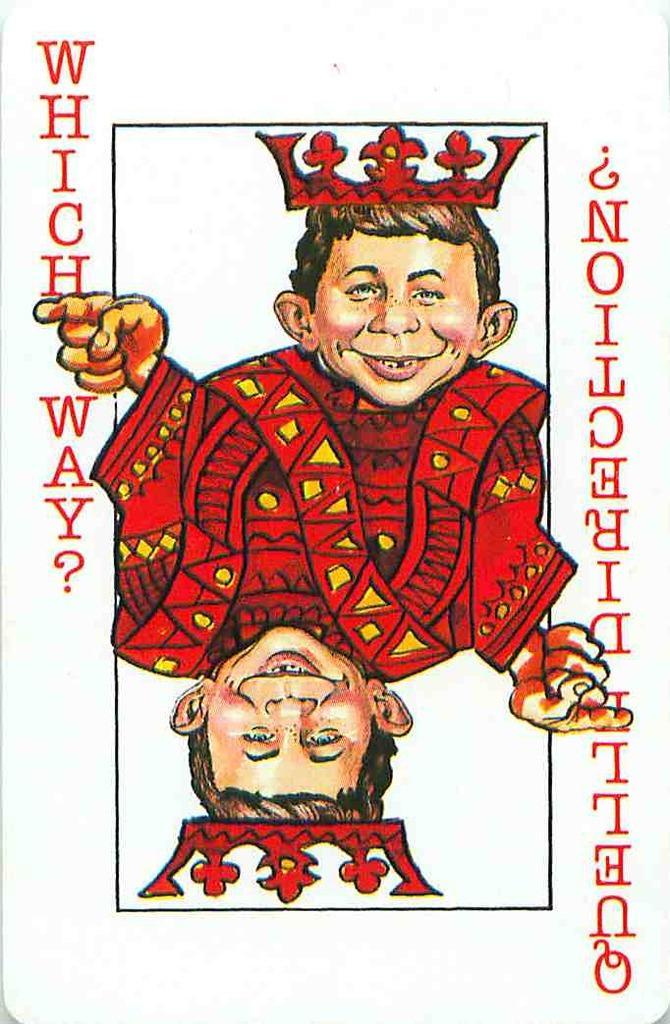Can you describe this image briefly? In this picture we can see a card with images. On the card, it is written something. 